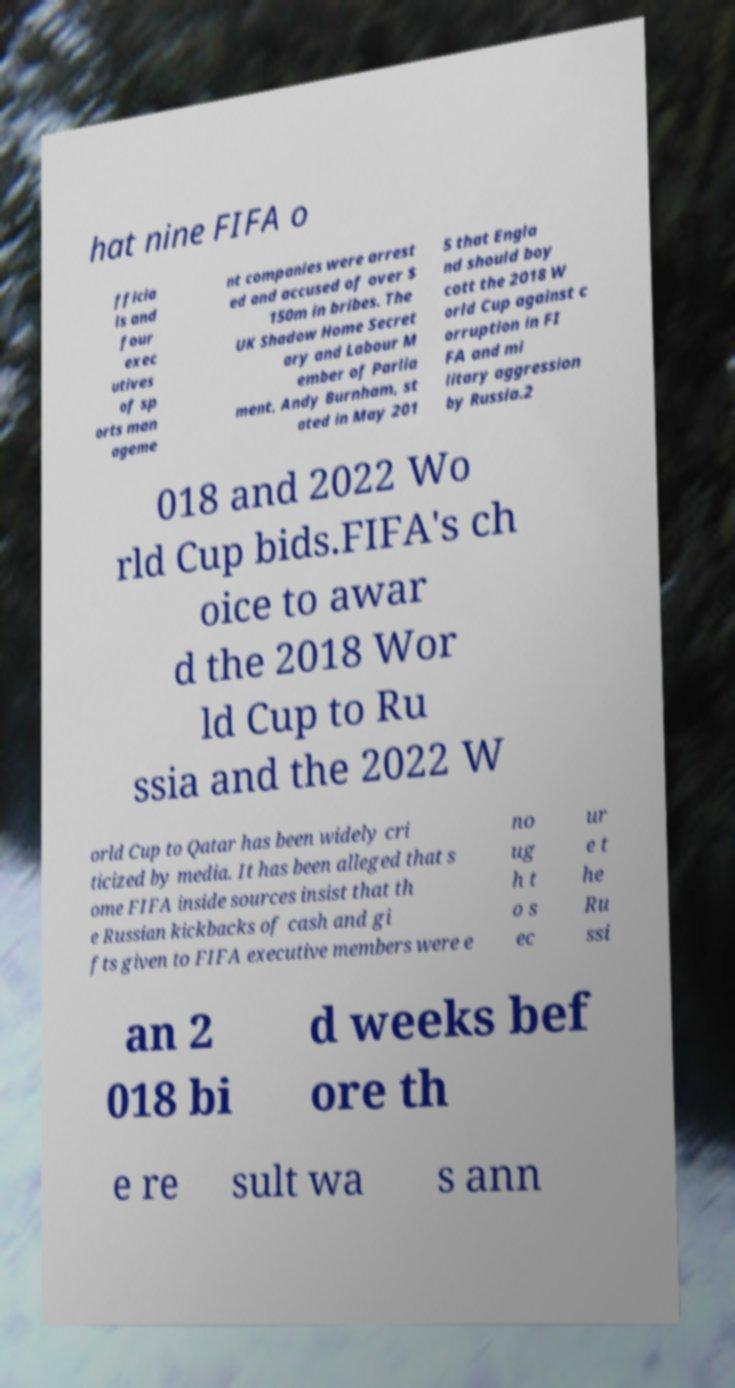I need the written content from this picture converted into text. Can you do that? hat nine FIFA o fficia ls and four exec utives of sp orts man ageme nt companies were arrest ed and accused of over $ 150m in bribes. The UK Shadow Home Secret ary and Labour M ember of Parlia ment, Andy Burnham, st ated in May 201 5 that Engla nd should boy cott the 2018 W orld Cup against c orruption in FI FA and mi litary aggression by Russia.2 018 and 2022 Wo rld Cup bids.FIFA's ch oice to awar d the 2018 Wor ld Cup to Ru ssia and the 2022 W orld Cup to Qatar has been widely cri ticized by media. It has been alleged that s ome FIFA inside sources insist that th e Russian kickbacks of cash and gi fts given to FIFA executive members were e no ug h t o s ec ur e t he Ru ssi an 2 018 bi d weeks bef ore th e re sult wa s ann 